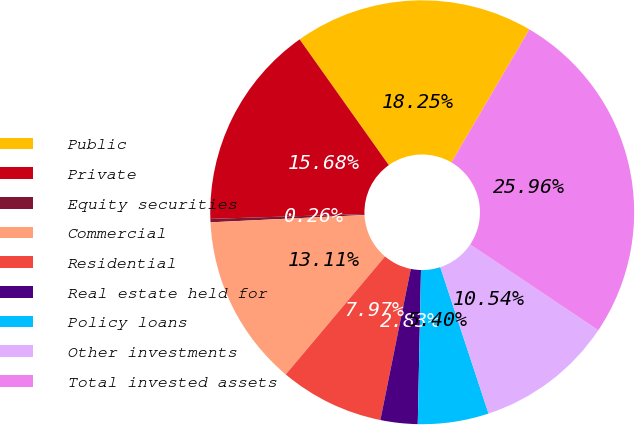<chart> <loc_0><loc_0><loc_500><loc_500><pie_chart><fcel>Public<fcel>Private<fcel>Equity securities<fcel>Commercial<fcel>Residential<fcel>Real estate held for<fcel>Policy loans<fcel>Other investments<fcel>Total invested assets<nl><fcel>18.25%<fcel>15.68%<fcel>0.26%<fcel>13.11%<fcel>7.97%<fcel>2.83%<fcel>5.4%<fcel>10.54%<fcel>25.96%<nl></chart> 